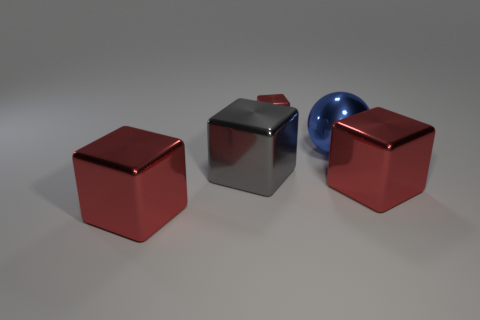Subtract all big gray metallic cubes. How many cubes are left? 3 Subtract 1 balls. How many balls are left? 0 Subtract all balls. How many objects are left? 4 Subtract all gray cubes. How many cubes are left? 3 Subtract all yellow cylinders. How many red blocks are left? 3 Subtract all large red shiny things. Subtract all small red shiny things. How many objects are left? 2 Add 2 big blue things. How many big blue things are left? 3 Add 2 big things. How many big things exist? 6 Add 2 tiny brown spheres. How many objects exist? 7 Subtract 0 brown cubes. How many objects are left? 5 